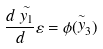<formula> <loc_0><loc_0><loc_500><loc_500>\frac { d \stackrel { \sim } { y _ { 1 } } } d \varepsilon = \phi ( \stackrel { \sim } { y } _ { 3 } )</formula> 